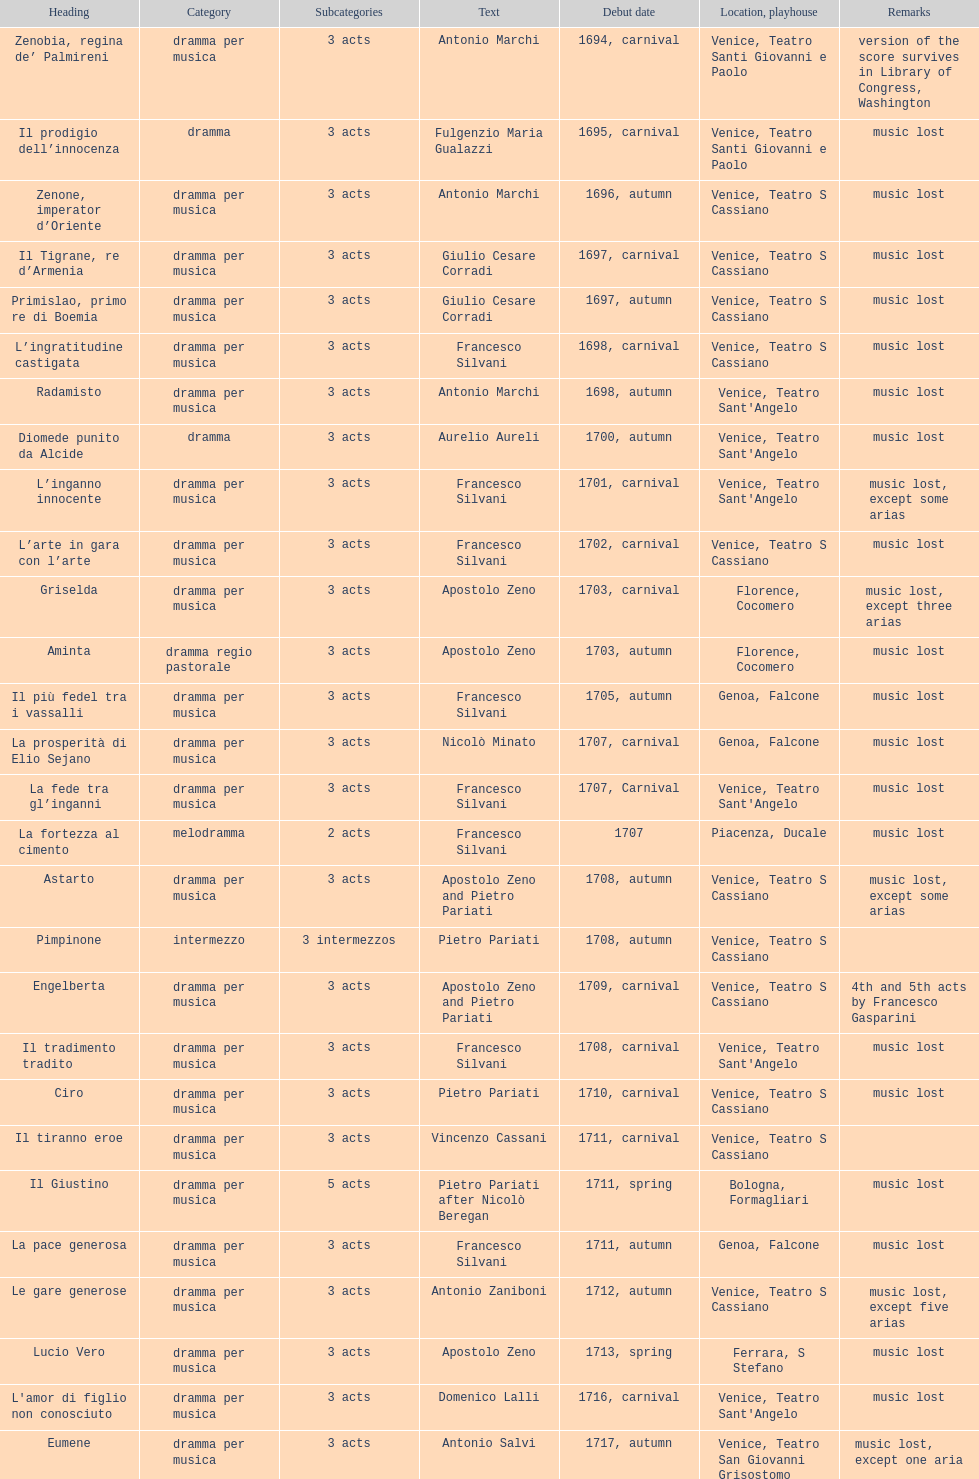What number of acts does il giustino have? 5. 